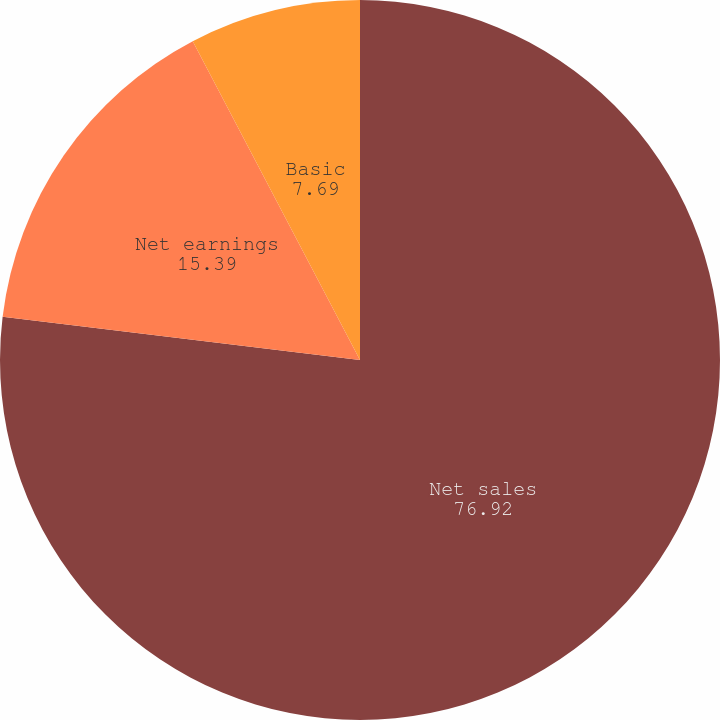Convert chart to OTSL. <chart><loc_0><loc_0><loc_500><loc_500><pie_chart><fcel>Net sales<fcel>Net earnings<fcel>Basic<fcel>Diluted<nl><fcel>76.92%<fcel>15.39%<fcel>7.69%<fcel>0.0%<nl></chart> 